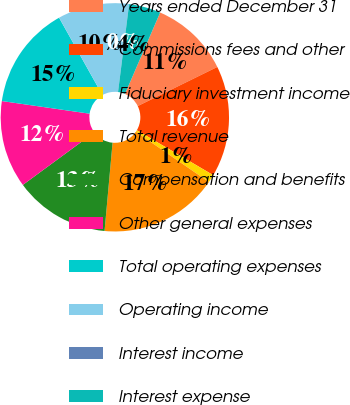<chart> <loc_0><loc_0><loc_500><loc_500><pie_chart><fcel>Years ended December 31<fcel>Commissions fees and other<fcel>Fiduciary investment income<fcel>Total revenue<fcel>Compensation and benefits<fcel>Other general expenses<fcel>Total operating expenses<fcel>Operating income<fcel>Interest income<fcel>Interest expense<nl><fcel>11.23%<fcel>15.73%<fcel>1.13%<fcel>16.85%<fcel>13.48%<fcel>12.36%<fcel>14.6%<fcel>10.11%<fcel>0.01%<fcel>4.5%<nl></chart> 